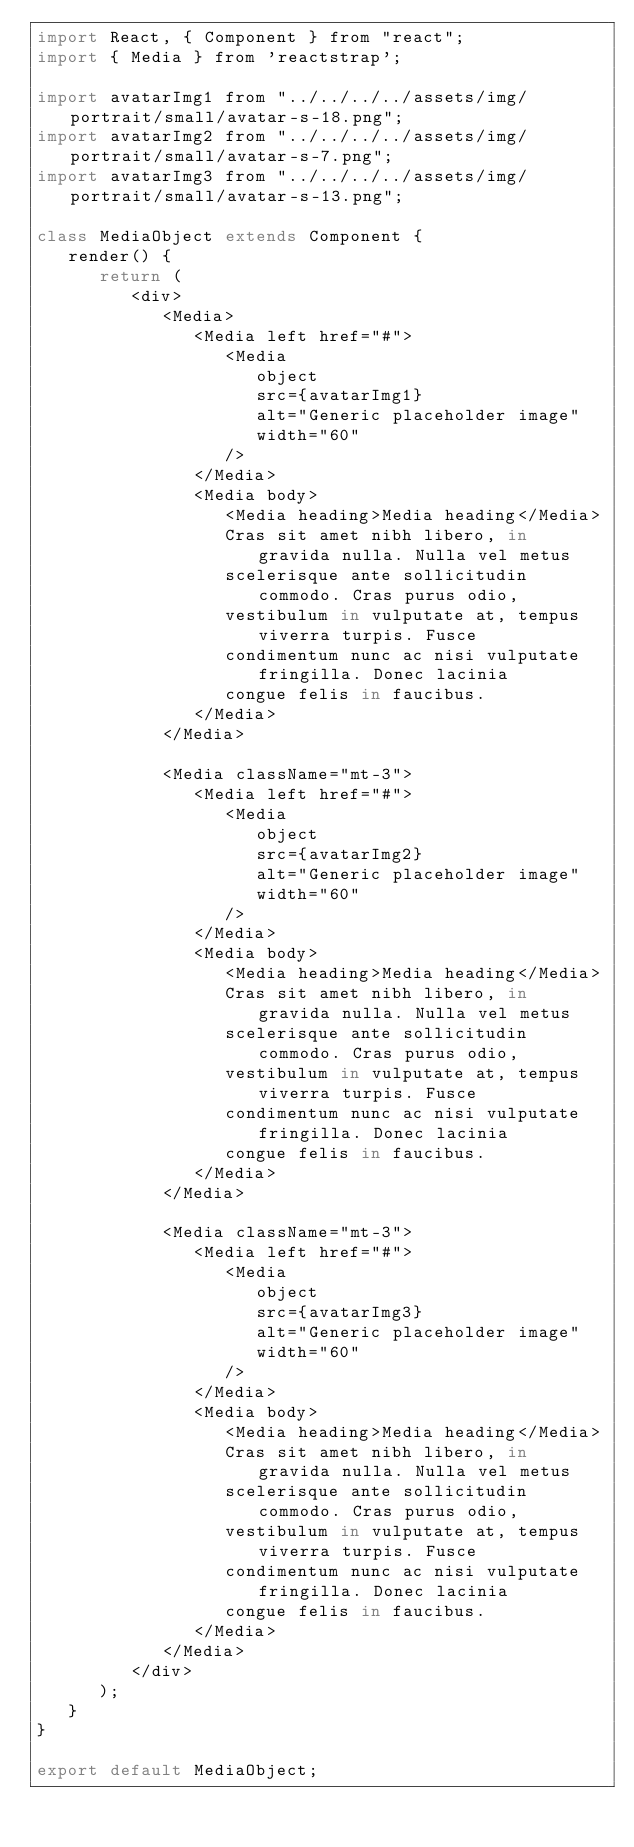<code> <loc_0><loc_0><loc_500><loc_500><_JavaScript_>import React, { Component } from "react";
import { Media } from 'reactstrap';

import avatarImg1 from "../../../../assets/img/portrait/small/avatar-s-18.png";
import avatarImg2 from "../../../../assets/img/portrait/small/avatar-s-7.png";
import avatarImg3 from "../../../../assets/img/portrait/small/avatar-s-13.png";

class MediaObject extends Component {
   render() {
      return (
         <div>
            <Media>
               <Media left href="#">
                  <Media
                     object
                     src={avatarImg1}
                     alt="Generic placeholder image"
                     width="60"
                  />
               </Media>
               <Media body>
                  <Media heading>Media heading</Media>
                  Cras sit amet nibh libero, in gravida nulla. Nulla vel metus
                  scelerisque ante sollicitudin commodo. Cras purus odio,
                  vestibulum in vulputate at, tempus viverra turpis. Fusce
                  condimentum nunc ac nisi vulputate fringilla. Donec lacinia
                  congue felis in faucibus.
               </Media>
            </Media>

            <Media className="mt-3">
               <Media left href="#">
                  <Media
                     object
                     src={avatarImg2}
                     alt="Generic placeholder image"
                     width="60"
                  />
               </Media>
               <Media body>
                  <Media heading>Media heading</Media>
                  Cras sit amet nibh libero, in gravida nulla. Nulla vel metus
                  scelerisque ante sollicitudin commodo. Cras purus odio,
                  vestibulum in vulputate at, tempus viverra turpis. Fusce
                  condimentum nunc ac nisi vulputate fringilla. Donec lacinia
                  congue felis in faucibus.
               </Media>
            </Media>

            <Media className="mt-3">
               <Media left href="#">
                  <Media
                     object
                     src={avatarImg3}
                     alt="Generic placeholder image"
                     width="60"
                  />
               </Media>
               <Media body>
                  <Media heading>Media heading</Media>
                  Cras sit amet nibh libero, in gravida nulla. Nulla vel metus
                  scelerisque ante sollicitudin commodo. Cras purus odio,
                  vestibulum in vulputate at, tempus viverra turpis. Fusce
                  condimentum nunc ac nisi vulputate fringilla. Donec lacinia
                  congue felis in faucibus.
               </Media>
            </Media>
         </div>
      );
   }
}

export default MediaObject;
</code> 